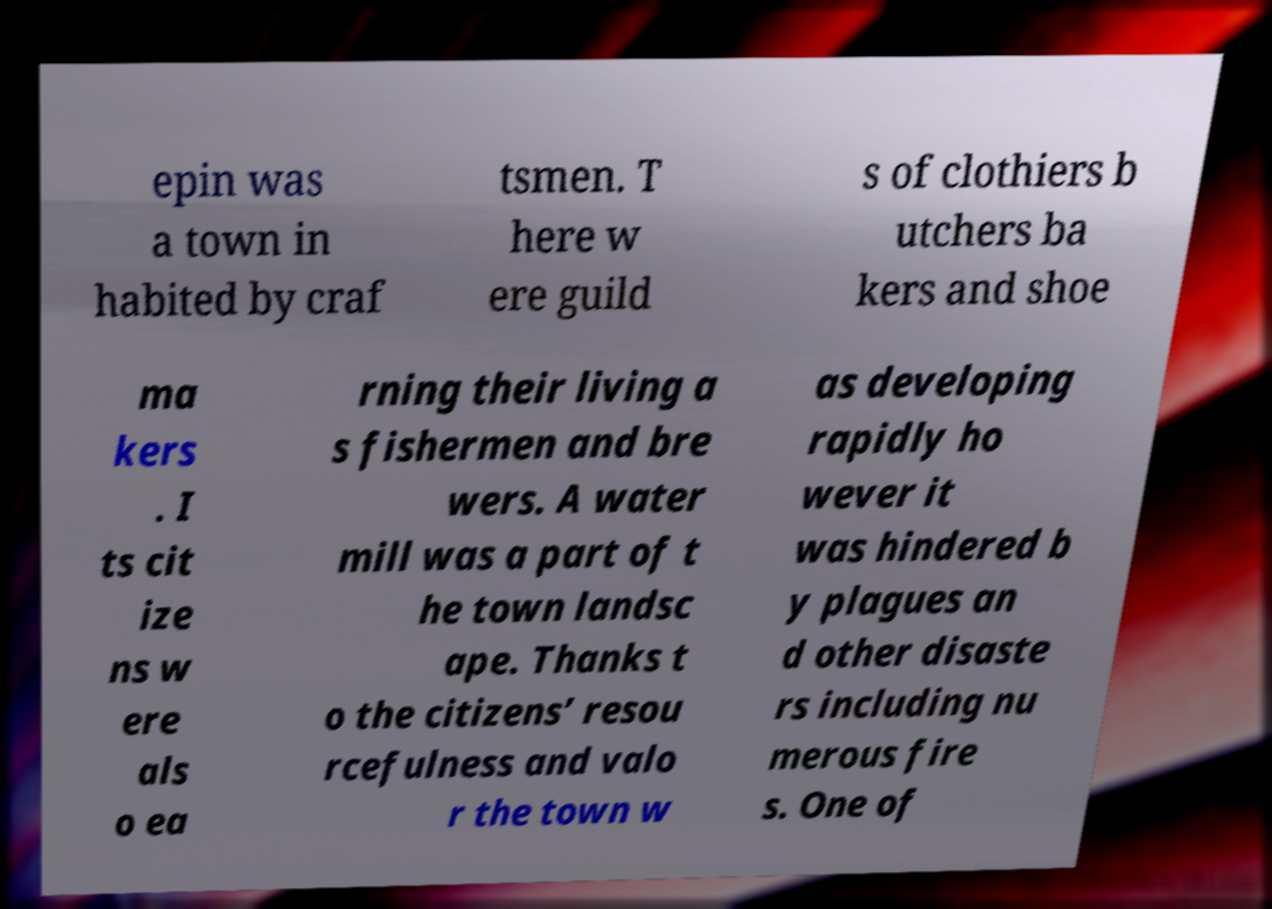Could you extract and type out the text from this image? epin was a town in habited by craf tsmen. T here w ere guild s of clothiers b utchers ba kers and shoe ma kers . I ts cit ize ns w ere als o ea rning their living a s fishermen and bre wers. A water mill was a part of t he town landsc ape. Thanks t o the citizens’ resou rcefulness and valo r the town w as developing rapidly ho wever it was hindered b y plagues an d other disaste rs including nu merous fire s. One of 